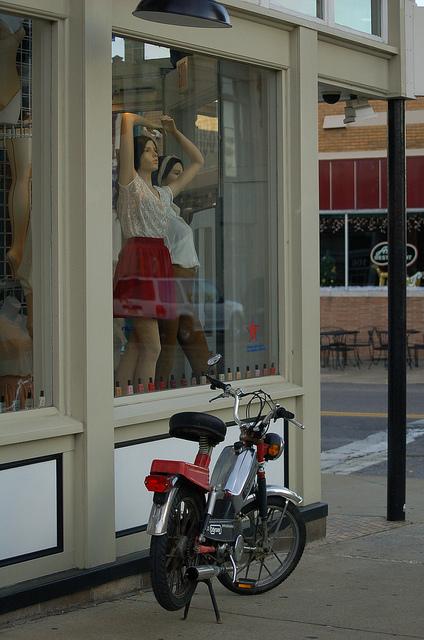What is this vehicle?
Give a very brief answer. Bike. Is the woman wearing a miniskirt?
Answer briefly. Yes. Where is the bike parked?
Short answer required. Sidewalk. Is that a person in the window?
Give a very brief answer. No. Are they wearing helmets?
Be succinct. No. Is the bike moving?
Answer briefly. No. Do you like this motorcycle?
Write a very short answer. Yes. Where is the motorcycle parked?
Be succinct. Sidewalk. 